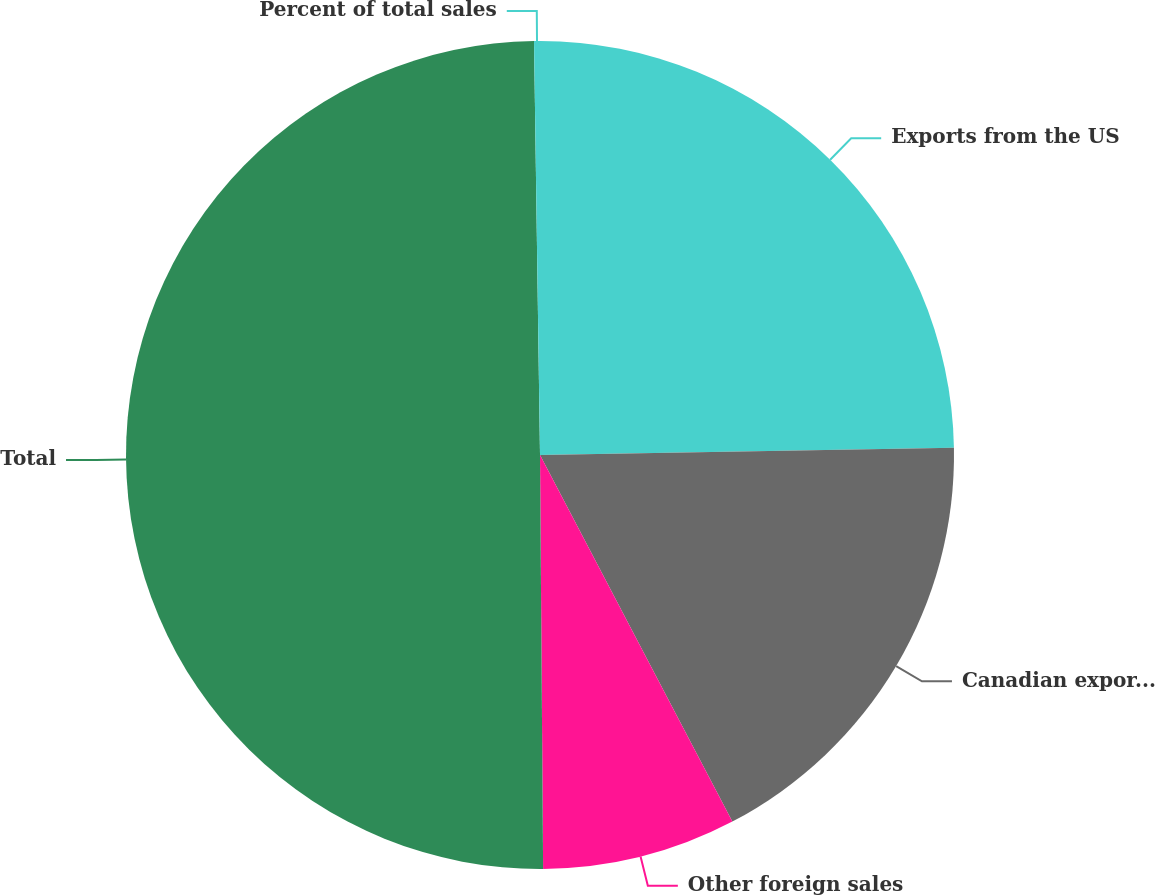Convert chart. <chart><loc_0><loc_0><loc_500><loc_500><pie_chart><fcel>Exports from the US<fcel>Canadian export and domestic<fcel>Other foreign sales<fcel>Total<fcel>Percent of total sales<nl><fcel>24.72%<fcel>17.59%<fcel>7.57%<fcel>49.89%<fcel>0.23%<nl></chart> 